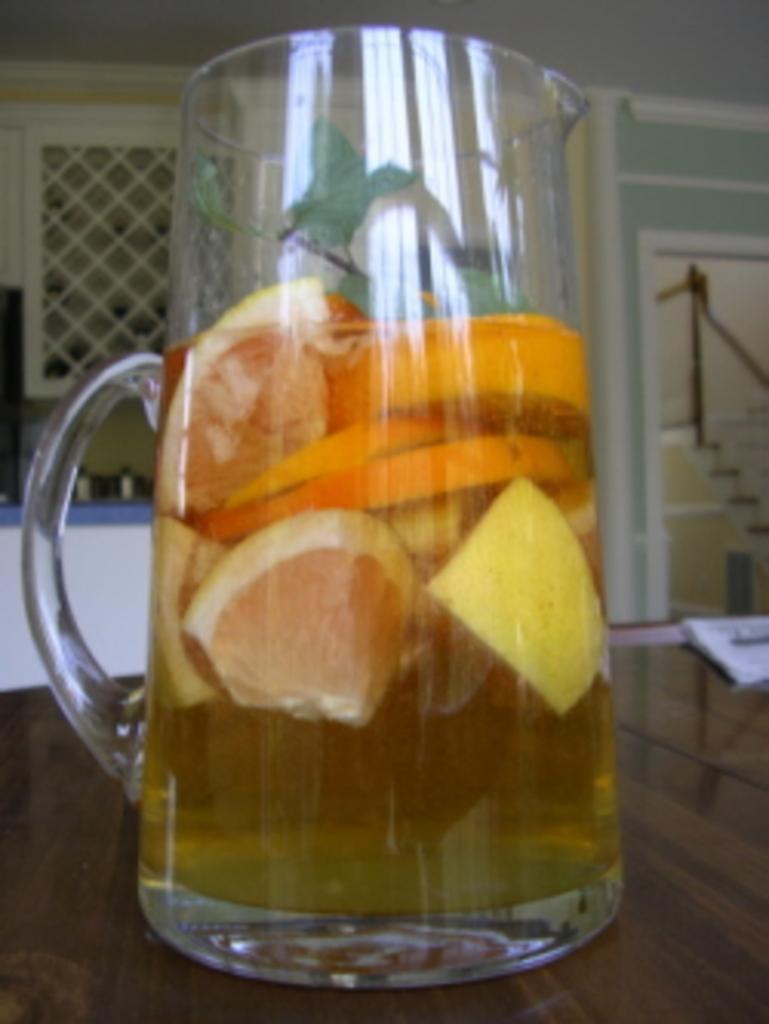How would you summarize this image in a sentence or two? In the picture I can see a glass of lemon juice on the wooden table. It is looking like papers on the table on the right side. I can see the metal grill fence on the left side. 